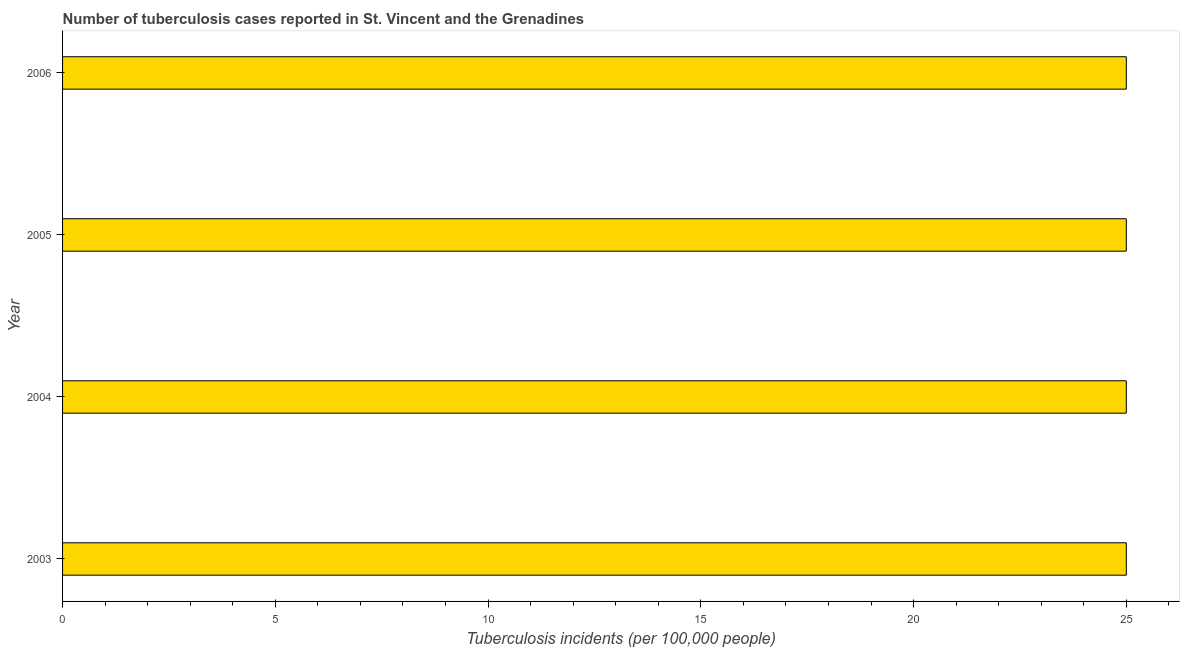What is the title of the graph?
Offer a terse response. Number of tuberculosis cases reported in St. Vincent and the Grenadines. What is the label or title of the X-axis?
Provide a succinct answer. Tuberculosis incidents (per 100,0 people). What is the label or title of the Y-axis?
Your answer should be compact. Year. What is the number of tuberculosis incidents in 2003?
Your answer should be very brief. 25. Across all years, what is the minimum number of tuberculosis incidents?
Give a very brief answer. 25. In which year was the number of tuberculosis incidents maximum?
Give a very brief answer. 2003. In which year was the number of tuberculosis incidents minimum?
Your answer should be compact. 2003. What is the sum of the number of tuberculosis incidents?
Ensure brevity in your answer.  100. What is the median number of tuberculosis incidents?
Provide a succinct answer. 25. What is the ratio of the number of tuberculosis incidents in 2004 to that in 2005?
Provide a short and direct response. 1. Is the difference between the number of tuberculosis incidents in 2005 and 2006 greater than the difference between any two years?
Give a very brief answer. Yes. What is the difference between the highest and the second highest number of tuberculosis incidents?
Offer a very short reply. 0. Is the sum of the number of tuberculosis incidents in 2004 and 2005 greater than the maximum number of tuberculosis incidents across all years?
Your answer should be very brief. Yes. In how many years, is the number of tuberculosis incidents greater than the average number of tuberculosis incidents taken over all years?
Make the answer very short. 0. Are all the bars in the graph horizontal?
Your answer should be very brief. Yes. Are the values on the major ticks of X-axis written in scientific E-notation?
Provide a succinct answer. No. What is the Tuberculosis incidents (per 100,000 people) in 2003?
Keep it short and to the point. 25. What is the Tuberculosis incidents (per 100,000 people) of 2004?
Offer a terse response. 25. What is the Tuberculosis incidents (per 100,000 people) of 2006?
Keep it short and to the point. 25. What is the difference between the Tuberculosis incidents (per 100,000 people) in 2003 and 2004?
Ensure brevity in your answer.  0. What is the difference between the Tuberculosis incidents (per 100,000 people) in 2003 and 2005?
Provide a short and direct response. 0. What is the difference between the Tuberculosis incidents (per 100,000 people) in 2004 and 2005?
Offer a very short reply. 0. What is the difference between the Tuberculosis incidents (per 100,000 people) in 2005 and 2006?
Your answer should be very brief. 0. What is the ratio of the Tuberculosis incidents (per 100,000 people) in 2005 to that in 2006?
Offer a very short reply. 1. 